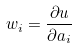<formula> <loc_0><loc_0><loc_500><loc_500>w _ { i } = \frac { \partial u } { \partial a _ { i } }</formula> 